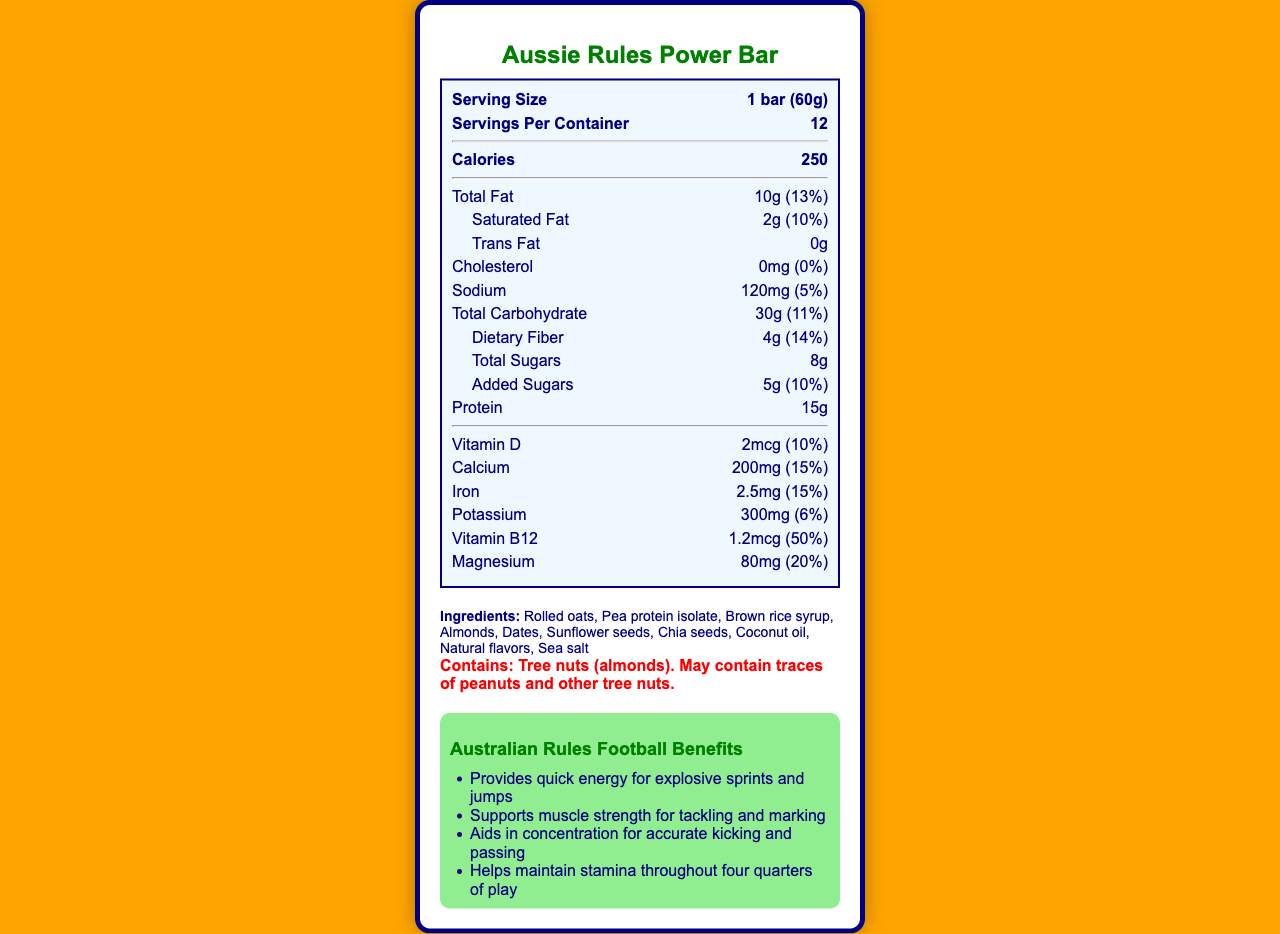what is the serving size? The serving size is stated as "1 bar (60g)" in the document.
Answer: 1 bar (60g) how many calories does one serving contain? The document specifies that there are 250 calories per serving.
Answer: 250 what is the total amount of protein in one bar? The amount of protein is listed as 15g per serving in the nutrition label.
Answer: 15g how much dietary fiber does the bar have? The nutrition label shows that the bar contains 4g of dietary fiber per serving.
Answer: 4g what are the main ingredients in the Aussie Rules Power Bar? The ingredients are listed as Rolled oats, Pea protein isolate, Brown rice syrup, Almonds, Dates, Sunflower seeds, Chia seeds, Coconut oil, Natural flavors, and Sea salt.
Answer: Rolled oats, Pea protein isolate, Brown rice syrup, Almonds, Dates, Sunflower seeds, Chia seeds, Coconut oil, Natural flavors, Sea salt how much sugar is in the bar, including added sugars? The document states the total sugars as 8g and added sugars as 5g.
Answer: 8g total sugars, 5g added sugars is there any cholesterol in the bar? The nutrition label specifies that there is 0mg of cholesterol in the bar.
Answer: No, 0mg what is the percentage daily value of magnesium in the bar? The document states that the daily value of magnesium is 20%.
Answer: 20% which vitamin has the highest percentage daily value in the bar? A. Vitamin D B. Calcium C. Vitamin B12 D. Iron The percentage daily value for Vitamin B12 is 50%, which is higher than Vitamin D (10%), Calcium (15%), and Iron (15%).
Answer: C. Vitamin B12 which allergen is contained in the bar? A. Peanuts B. Wheat C. Tree nuts (almonds) D. Dairy The document states that the bar contains tree nuts (almonds).
Answer: C. Tree nuts (almonds) how many servings are there in one container? The document specifies that there are 12 servings per container.
Answer: 12 does the Aussie Rules Power Bar contain any trans fat? The document shows that the trans fat content is 0g.
Answer: No what is the total carbohydrate content in one serving? The total carbohydrate content is listed as 30g, with a daily value of 11%.
Answer: 30g (11%) does the bar help in muscle recovery? One of the performance claims of the bar is that it is high in protein for muscle recovery.
Answer: Yes summarize the main purpose of the document. The document includes a detailed nutrition label, a list of ingredients and allergens, performance claims, and the benefits of the bar for Australian Rules football players.
Answer: The document provides the nutrition facts and benefits of the Aussie Rules Power Bar, emphasizing its balanced macronutrients, high protein content, essential vitamins and minerals, and specific benefits for Australian Rules football players. what flavors are available for the Aussie Rules Power Bar? The document does not provide any information regarding the different flavors available for the Aussie Rules Power Bar.
Answer: Not enough information 